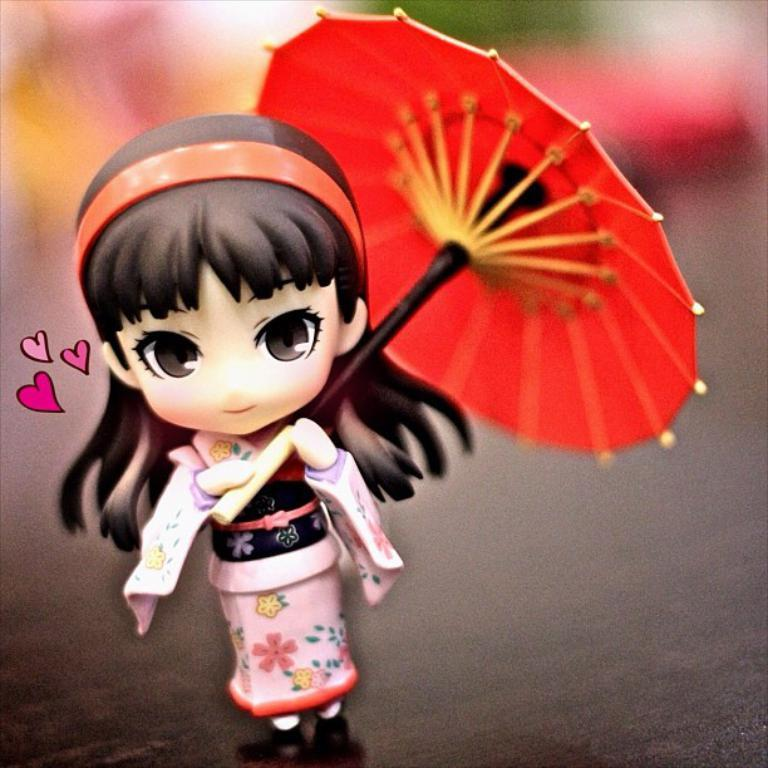What is placed on a surface in the image? There is a doll placed on a surface in the image. What type of monkey can be seen playing with a bubble in the image? There is no monkey or bubble present in the image; it only features a doll placed on a surface. 